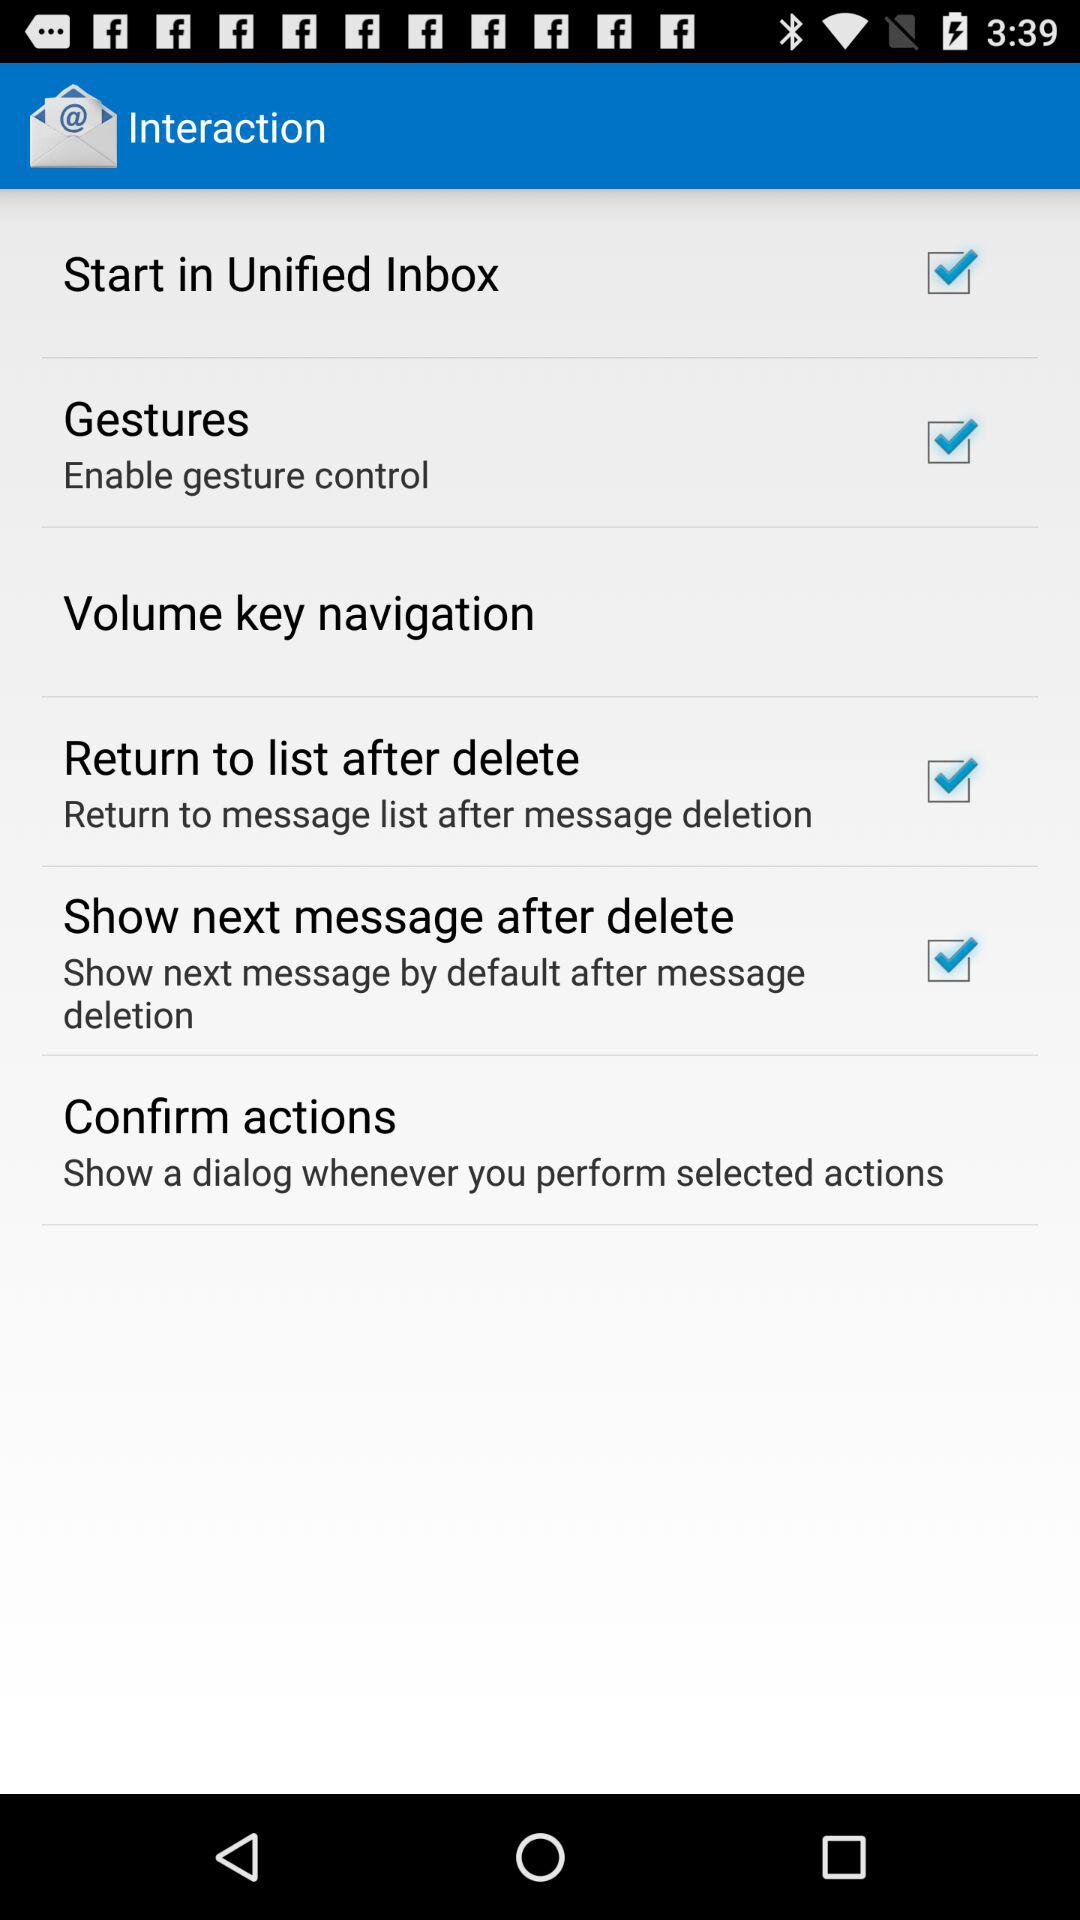What is the status of "Gestures"? The status is "on". 